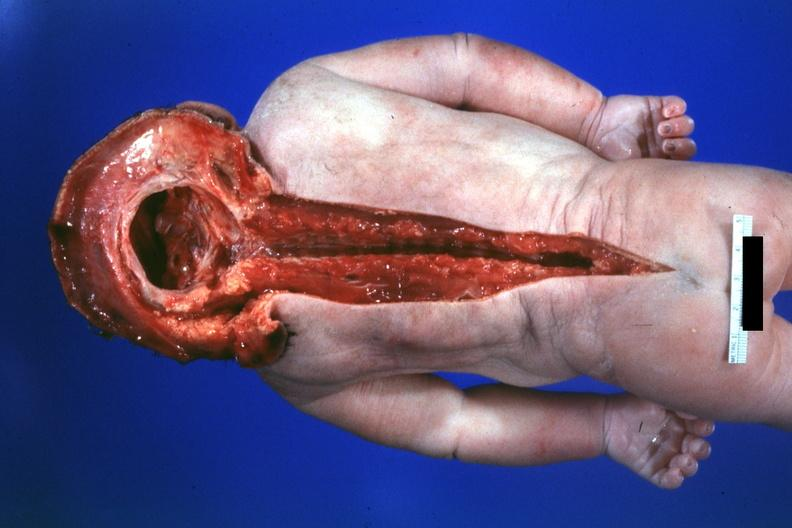what does this image show?
Answer the question using a single word or phrase. Dysraphism encephalocele occipital premature female no chromosomal defects lived one day 